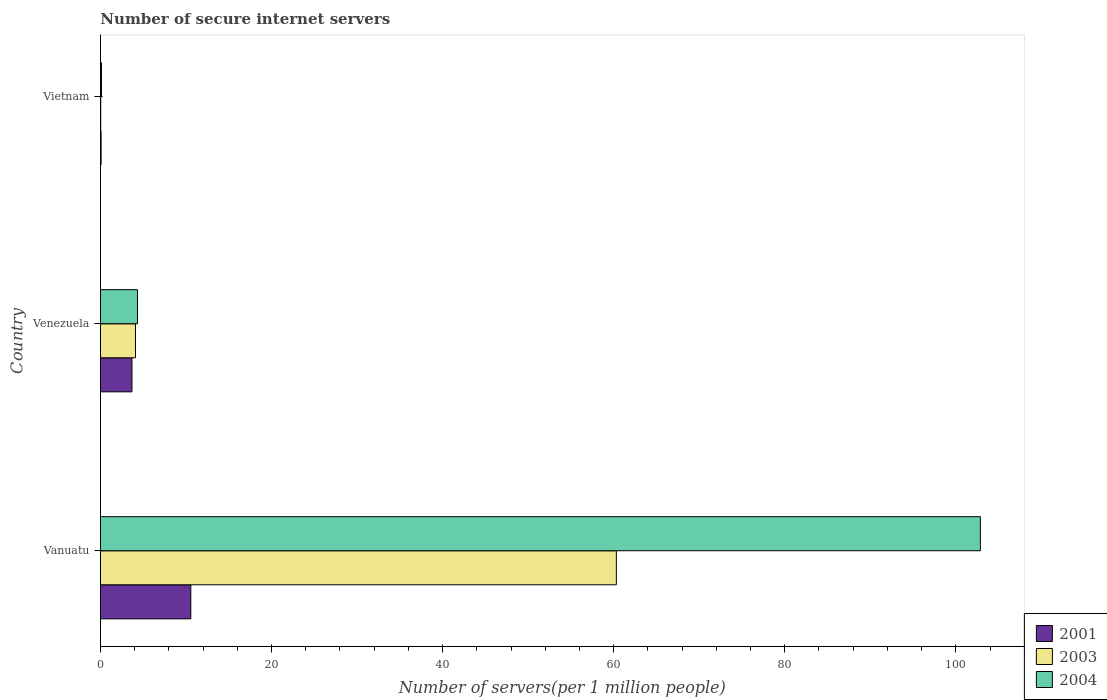How many groups of bars are there?
Provide a short and direct response. 3. Are the number of bars per tick equal to the number of legend labels?
Offer a very short reply. Yes. How many bars are there on the 1st tick from the bottom?
Your response must be concise. 3. What is the label of the 1st group of bars from the top?
Offer a terse response. Vietnam. What is the number of secure internet servers in 2003 in Vietnam?
Ensure brevity in your answer.  0.04. Across all countries, what is the maximum number of secure internet servers in 2003?
Ensure brevity in your answer.  60.31. Across all countries, what is the minimum number of secure internet servers in 2003?
Provide a succinct answer. 0.04. In which country was the number of secure internet servers in 2004 maximum?
Your response must be concise. Vanuatu. In which country was the number of secure internet servers in 2003 minimum?
Your answer should be compact. Vietnam. What is the total number of secure internet servers in 2004 in the graph?
Your answer should be very brief. 107.32. What is the difference between the number of secure internet servers in 2004 in Vanuatu and that in Venezuela?
Your answer should be very brief. 98.54. What is the difference between the number of secure internet servers in 2003 in Vietnam and the number of secure internet servers in 2001 in Venezuela?
Ensure brevity in your answer.  -3.65. What is the average number of secure internet servers in 2001 per country?
Your response must be concise. 4.78. What is the difference between the number of secure internet servers in 2001 and number of secure internet servers in 2003 in Vanuatu?
Your response must be concise. -49.75. In how many countries, is the number of secure internet servers in 2004 greater than 44 ?
Offer a terse response. 1. What is the ratio of the number of secure internet servers in 2004 in Vanuatu to that in Venezuela?
Offer a terse response. 23.75. What is the difference between the highest and the second highest number of secure internet servers in 2003?
Offer a very short reply. 56.21. What is the difference between the highest and the lowest number of secure internet servers in 2003?
Give a very brief answer. 60.28. Is the sum of the number of secure internet servers in 2004 in Vanuatu and Vietnam greater than the maximum number of secure internet servers in 2001 across all countries?
Your answer should be very brief. Yes. How many bars are there?
Ensure brevity in your answer.  9. Are all the bars in the graph horizontal?
Keep it short and to the point. Yes. Are the values on the major ticks of X-axis written in scientific E-notation?
Keep it short and to the point. No. Does the graph contain grids?
Give a very brief answer. No. Where does the legend appear in the graph?
Provide a succinct answer. Bottom right. What is the title of the graph?
Provide a succinct answer. Number of secure internet servers. What is the label or title of the X-axis?
Provide a short and direct response. Number of servers(per 1 million people). What is the Number of servers(per 1 million people) in 2001 in Vanuatu?
Provide a short and direct response. 10.57. What is the Number of servers(per 1 million people) in 2003 in Vanuatu?
Offer a terse response. 60.31. What is the Number of servers(per 1 million people) of 2004 in Vanuatu?
Offer a terse response. 102.87. What is the Number of servers(per 1 million people) of 2001 in Venezuela?
Keep it short and to the point. 3.69. What is the Number of servers(per 1 million people) in 2003 in Venezuela?
Offer a very short reply. 4.1. What is the Number of servers(per 1 million people) of 2004 in Venezuela?
Keep it short and to the point. 4.33. What is the Number of servers(per 1 million people) in 2001 in Vietnam?
Your response must be concise. 0.08. What is the Number of servers(per 1 million people) of 2003 in Vietnam?
Offer a very short reply. 0.04. What is the Number of servers(per 1 million people) in 2004 in Vietnam?
Your answer should be very brief. 0.12. Across all countries, what is the maximum Number of servers(per 1 million people) in 2001?
Your response must be concise. 10.57. Across all countries, what is the maximum Number of servers(per 1 million people) in 2003?
Provide a short and direct response. 60.31. Across all countries, what is the maximum Number of servers(per 1 million people) of 2004?
Provide a short and direct response. 102.87. Across all countries, what is the minimum Number of servers(per 1 million people) of 2001?
Offer a very short reply. 0.08. Across all countries, what is the minimum Number of servers(per 1 million people) of 2003?
Ensure brevity in your answer.  0.04. Across all countries, what is the minimum Number of servers(per 1 million people) of 2004?
Provide a short and direct response. 0.12. What is the total Number of servers(per 1 million people) of 2001 in the graph?
Give a very brief answer. 14.33. What is the total Number of servers(per 1 million people) in 2003 in the graph?
Your answer should be very brief. 64.45. What is the total Number of servers(per 1 million people) in 2004 in the graph?
Keep it short and to the point. 107.32. What is the difference between the Number of servers(per 1 million people) in 2001 in Vanuatu and that in Venezuela?
Your response must be concise. 6.88. What is the difference between the Number of servers(per 1 million people) of 2003 in Vanuatu and that in Venezuela?
Offer a very short reply. 56.21. What is the difference between the Number of servers(per 1 million people) of 2004 in Vanuatu and that in Venezuela?
Provide a short and direct response. 98.54. What is the difference between the Number of servers(per 1 million people) of 2001 in Vanuatu and that in Vietnam?
Keep it short and to the point. 10.49. What is the difference between the Number of servers(per 1 million people) of 2003 in Vanuatu and that in Vietnam?
Make the answer very short. 60.28. What is the difference between the Number of servers(per 1 million people) in 2004 in Vanuatu and that in Vietnam?
Your response must be concise. 102.75. What is the difference between the Number of servers(per 1 million people) in 2001 in Venezuela and that in Vietnam?
Your answer should be very brief. 3.61. What is the difference between the Number of servers(per 1 million people) in 2003 in Venezuela and that in Vietnam?
Your answer should be very brief. 4.06. What is the difference between the Number of servers(per 1 million people) of 2004 in Venezuela and that in Vietnam?
Your response must be concise. 4.21. What is the difference between the Number of servers(per 1 million people) of 2001 in Vanuatu and the Number of servers(per 1 million people) of 2003 in Venezuela?
Your answer should be compact. 6.47. What is the difference between the Number of servers(per 1 million people) in 2001 in Vanuatu and the Number of servers(per 1 million people) in 2004 in Venezuela?
Your response must be concise. 6.23. What is the difference between the Number of servers(per 1 million people) in 2003 in Vanuatu and the Number of servers(per 1 million people) in 2004 in Venezuela?
Give a very brief answer. 55.98. What is the difference between the Number of servers(per 1 million people) in 2001 in Vanuatu and the Number of servers(per 1 million people) in 2003 in Vietnam?
Make the answer very short. 10.53. What is the difference between the Number of servers(per 1 million people) in 2001 in Vanuatu and the Number of servers(per 1 million people) in 2004 in Vietnam?
Offer a terse response. 10.44. What is the difference between the Number of servers(per 1 million people) of 2003 in Vanuatu and the Number of servers(per 1 million people) of 2004 in Vietnam?
Your response must be concise. 60.19. What is the difference between the Number of servers(per 1 million people) in 2001 in Venezuela and the Number of servers(per 1 million people) in 2003 in Vietnam?
Make the answer very short. 3.65. What is the difference between the Number of servers(per 1 million people) of 2001 in Venezuela and the Number of servers(per 1 million people) of 2004 in Vietnam?
Your answer should be compact. 3.57. What is the difference between the Number of servers(per 1 million people) in 2003 in Venezuela and the Number of servers(per 1 million people) in 2004 in Vietnam?
Your response must be concise. 3.98. What is the average Number of servers(per 1 million people) in 2001 per country?
Give a very brief answer. 4.78. What is the average Number of servers(per 1 million people) in 2003 per country?
Give a very brief answer. 21.48. What is the average Number of servers(per 1 million people) in 2004 per country?
Your answer should be very brief. 35.77. What is the difference between the Number of servers(per 1 million people) of 2001 and Number of servers(per 1 million people) of 2003 in Vanuatu?
Your response must be concise. -49.75. What is the difference between the Number of servers(per 1 million people) in 2001 and Number of servers(per 1 million people) in 2004 in Vanuatu?
Provide a short and direct response. -92.3. What is the difference between the Number of servers(per 1 million people) of 2003 and Number of servers(per 1 million people) of 2004 in Vanuatu?
Offer a very short reply. -42.56. What is the difference between the Number of servers(per 1 million people) in 2001 and Number of servers(per 1 million people) in 2003 in Venezuela?
Offer a very short reply. -0.41. What is the difference between the Number of servers(per 1 million people) of 2001 and Number of servers(per 1 million people) of 2004 in Venezuela?
Your answer should be compact. -0.64. What is the difference between the Number of servers(per 1 million people) of 2003 and Number of servers(per 1 million people) of 2004 in Venezuela?
Offer a terse response. -0.23. What is the difference between the Number of servers(per 1 million people) in 2001 and Number of servers(per 1 million people) in 2003 in Vietnam?
Make the answer very short. 0.04. What is the difference between the Number of servers(per 1 million people) of 2001 and Number of servers(per 1 million people) of 2004 in Vietnam?
Your answer should be compact. -0.05. What is the difference between the Number of servers(per 1 million people) of 2003 and Number of servers(per 1 million people) of 2004 in Vietnam?
Make the answer very short. -0.09. What is the ratio of the Number of servers(per 1 million people) of 2001 in Vanuatu to that in Venezuela?
Offer a very short reply. 2.86. What is the ratio of the Number of servers(per 1 million people) in 2003 in Vanuatu to that in Venezuela?
Your answer should be compact. 14.71. What is the ratio of the Number of servers(per 1 million people) of 2004 in Vanuatu to that in Venezuela?
Provide a succinct answer. 23.75. What is the ratio of the Number of servers(per 1 million people) in 2001 in Vanuatu to that in Vietnam?
Make the answer very short. 138.45. What is the ratio of the Number of servers(per 1 million people) of 2003 in Vanuatu to that in Vietnam?
Your answer should be very brief. 1617.74. What is the ratio of the Number of servers(per 1 million people) of 2004 in Vanuatu to that in Vietnam?
Keep it short and to the point. 837.72. What is the ratio of the Number of servers(per 1 million people) of 2001 in Venezuela to that in Vietnam?
Your answer should be compact. 48.34. What is the ratio of the Number of servers(per 1 million people) of 2003 in Venezuela to that in Vietnam?
Make the answer very short. 109.96. What is the ratio of the Number of servers(per 1 million people) of 2004 in Venezuela to that in Vietnam?
Ensure brevity in your answer.  35.28. What is the difference between the highest and the second highest Number of servers(per 1 million people) of 2001?
Make the answer very short. 6.88. What is the difference between the highest and the second highest Number of servers(per 1 million people) in 2003?
Offer a terse response. 56.21. What is the difference between the highest and the second highest Number of servers(per 1 million people) of 2004?
Keep it short and to the point. 98.54. What is the difference between the highest and the lowest Number of servers(per 1 million people) in 2001?
Your answer should be very brief. 10.49. What is the difference between the highest and the lowest Number of servers(per 1 million people) of 2003?
Ensure brevity in your answer.  60.28. What is the difference between the highest and the lowest Number of servers(per 1 million people) of 2004?
Your answer should be compact. 102.75. 